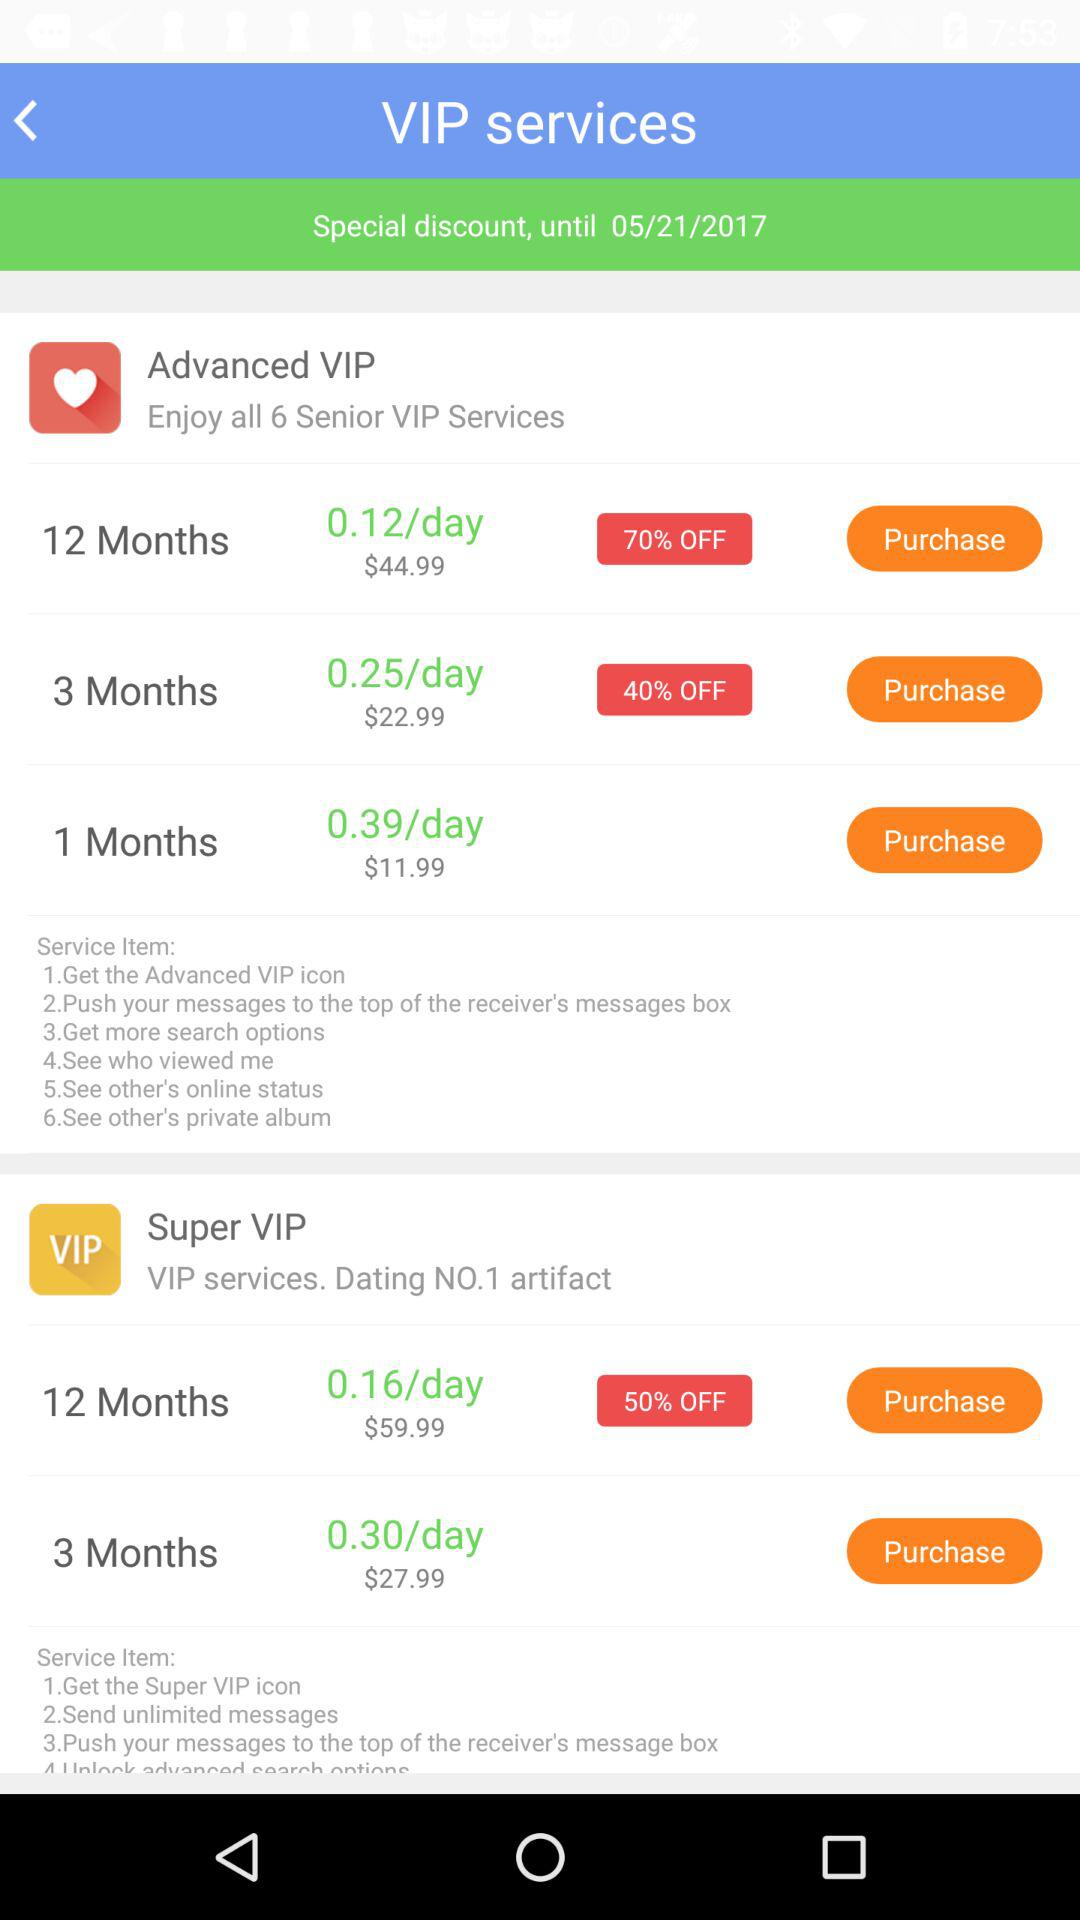What percentage is off on a Super VIP subscription for 12 months? The percentage off is 50. 